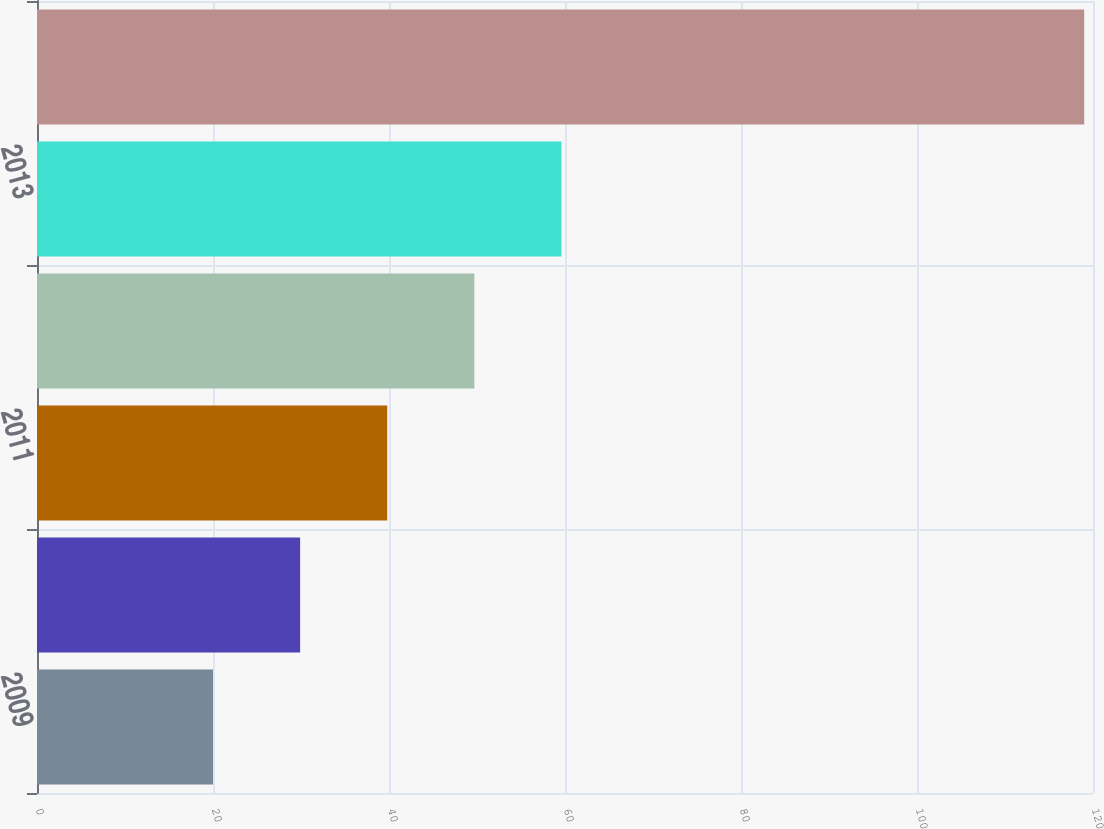Convert chart to OTSL. <chart><loc_0><loc_0><loc_500><loc_500><bar_chart><fcel>2009<fcel>2010<fcel>2011<fcel>2012<fcel>2013<fcel>2014 through 2018<nl><fcel>20<fcel>29.9<fcel>39.8<fcel>49.7<fcel>59.6<fcel>119<nl></chart> 